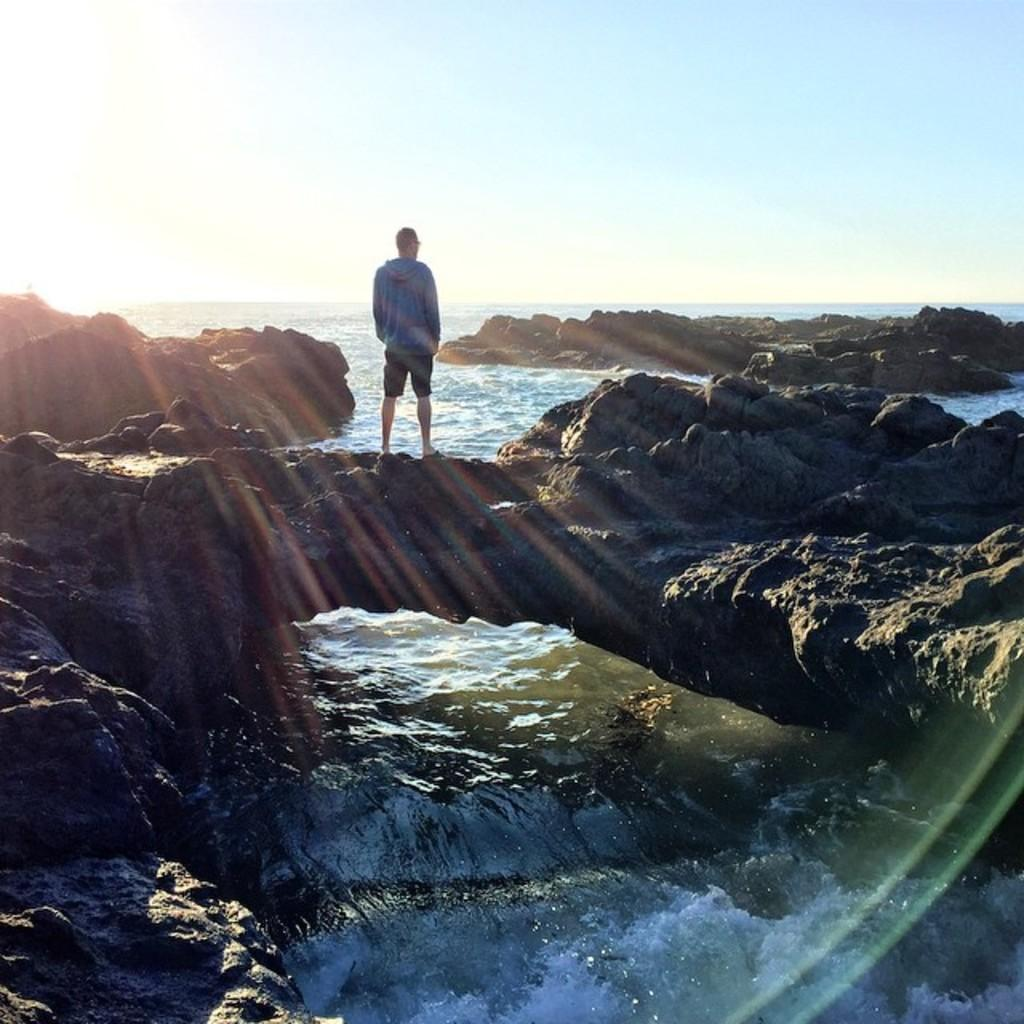What is the main subject of the image? There is a person standing in the image. What type of natural elements can be seen in the image? There are rocks and water visible in the image. What can be seen in the background of the image? The sky is visible in the background of the image. What type of unit is responsible for maintaining the dock in the image? There is no dock present in the image, so it is not possible to determine what type of unit might be responsible for maintaining it. 